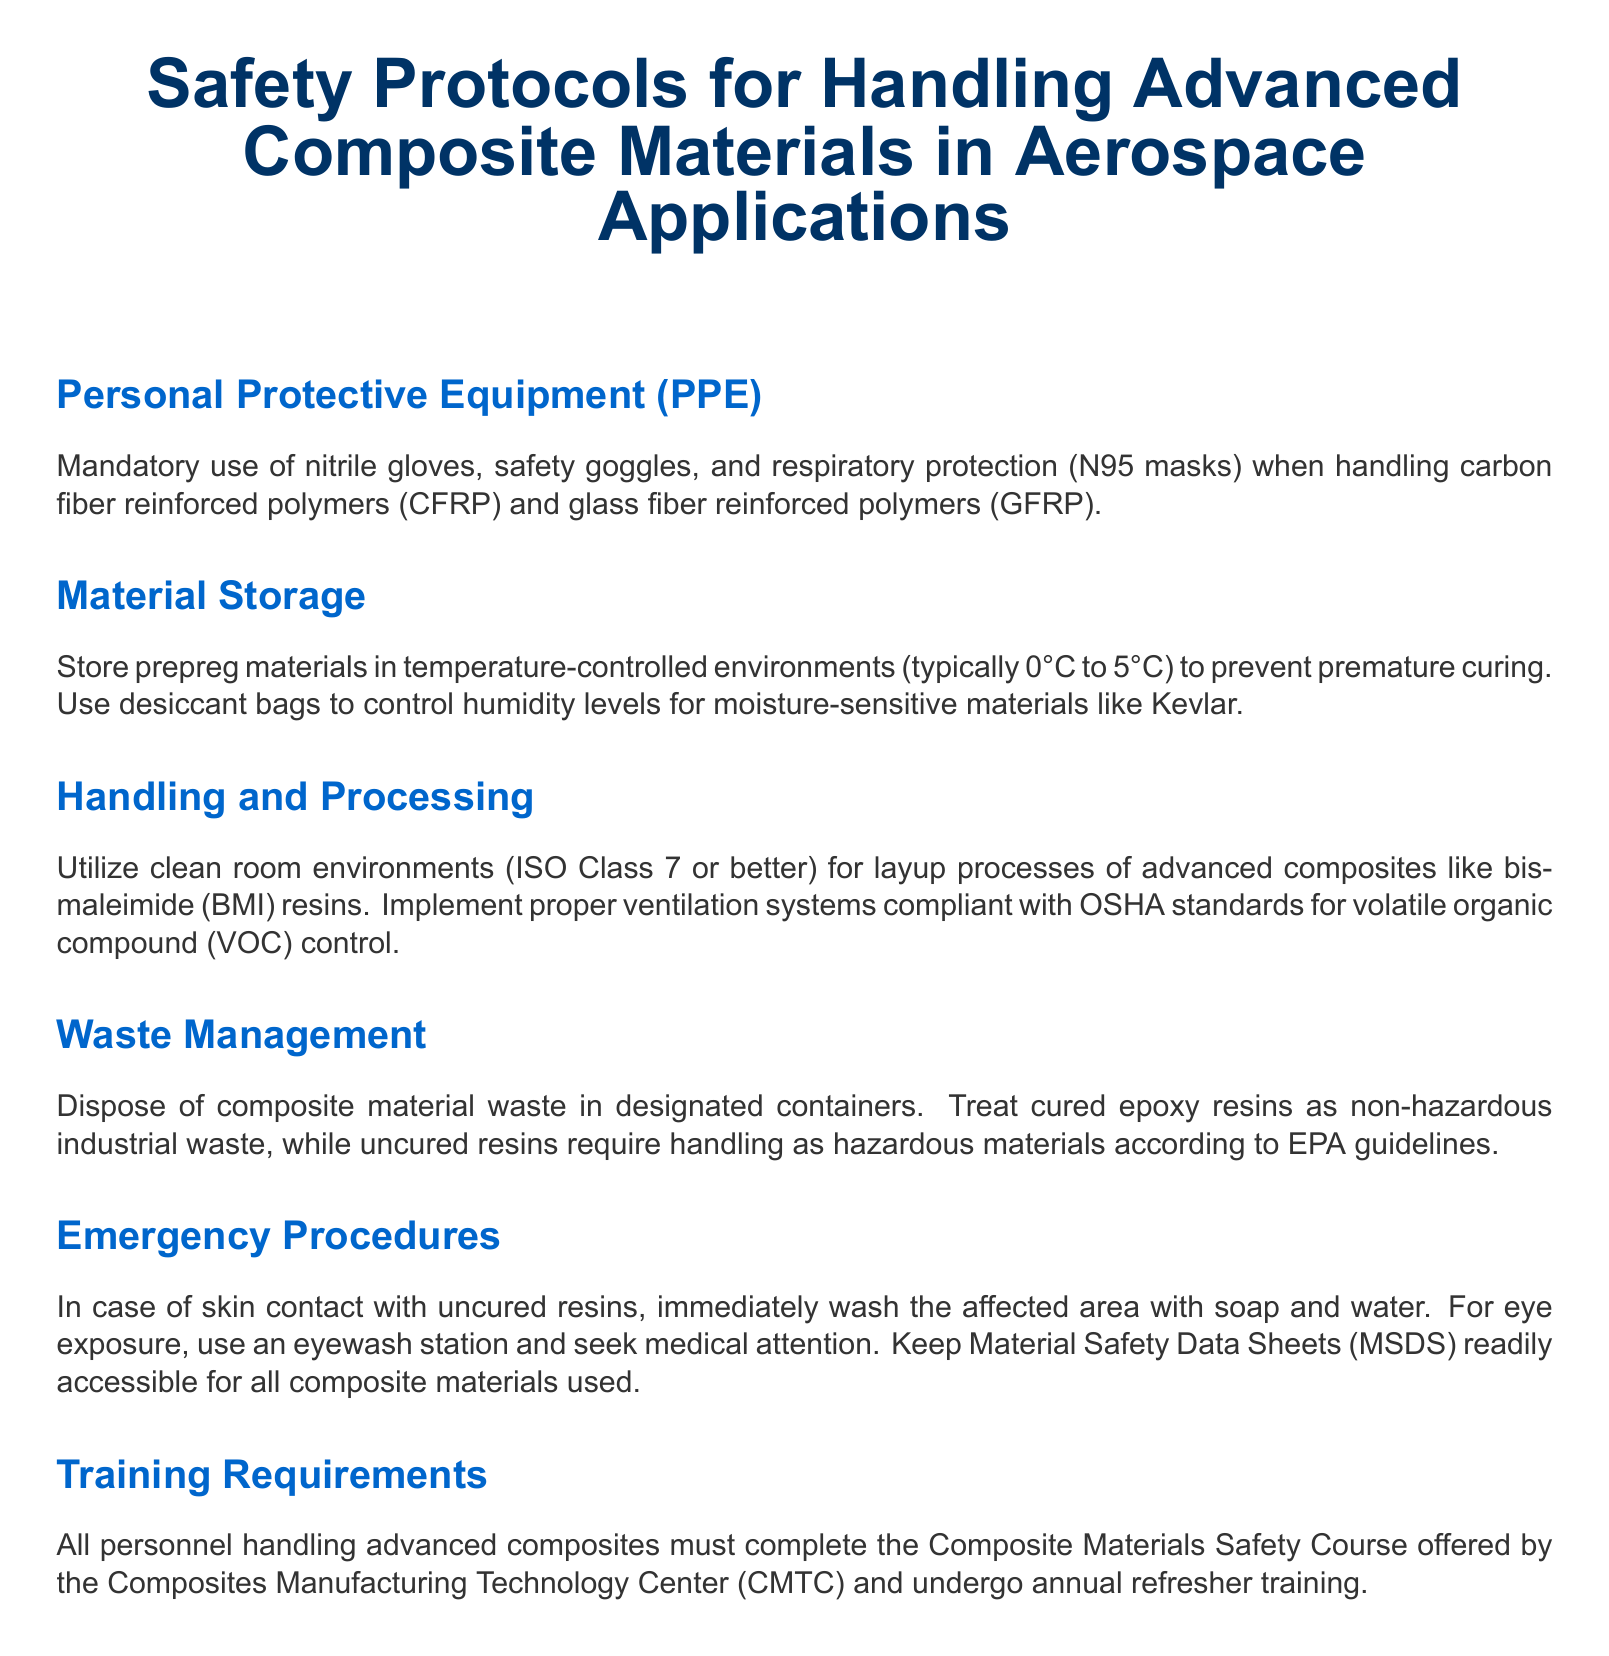What is the required PPE for handling CFRP? The required PPE includes nitrile gloves, safety goggles, and respiratory protection (N95 masks).
Answer: nitrile gloves, safety goggles, and respiratory protection (N95 masks) What temperature should prepreg materials be stored at? Prepreg materials should be stored in temperature-controlled environments between 0°C to 5°C.
Answer: 0°C to 5°C What class of clean room is recommended for layup processes? The document recommends using clean room environments of ISO Class 7 or better for layup processes.
Answer: ISO Class 7 How should cured epoxy resins be disposed of? Cured epoxy resins are treated as non-hazardous industrial waste for disposal.
Answer: non-hazardous industrial waste What action should be taken in case of eye exposure? The action to be taken is to use an eyewash station and seek medical attention.
Answer: use an eyewash station and seek medical attention What training course must personnel complete? Personnel must complete the Composite Materials Safety Course offered by the Composites Manufacturing Technology Center (CMTC).
Answer: Composite Materials Safety Course What is the humidity control method for moisture-sensitive materials? Desiccant bags are used to control humidity levels for moisture-sensitive materials like Kevlar.
Answer: desiccant bags What type of waste management is required for uncured resins? Uncured resins require handling as hazardous materials according to EPA guidelines.
Answer: hazardous materials according to EPA guidelines What organization provides the safety course? The safety course is offered by the Composites Manufacturing Technology Center.
Answer: Composites Manufacturing Technology Center 